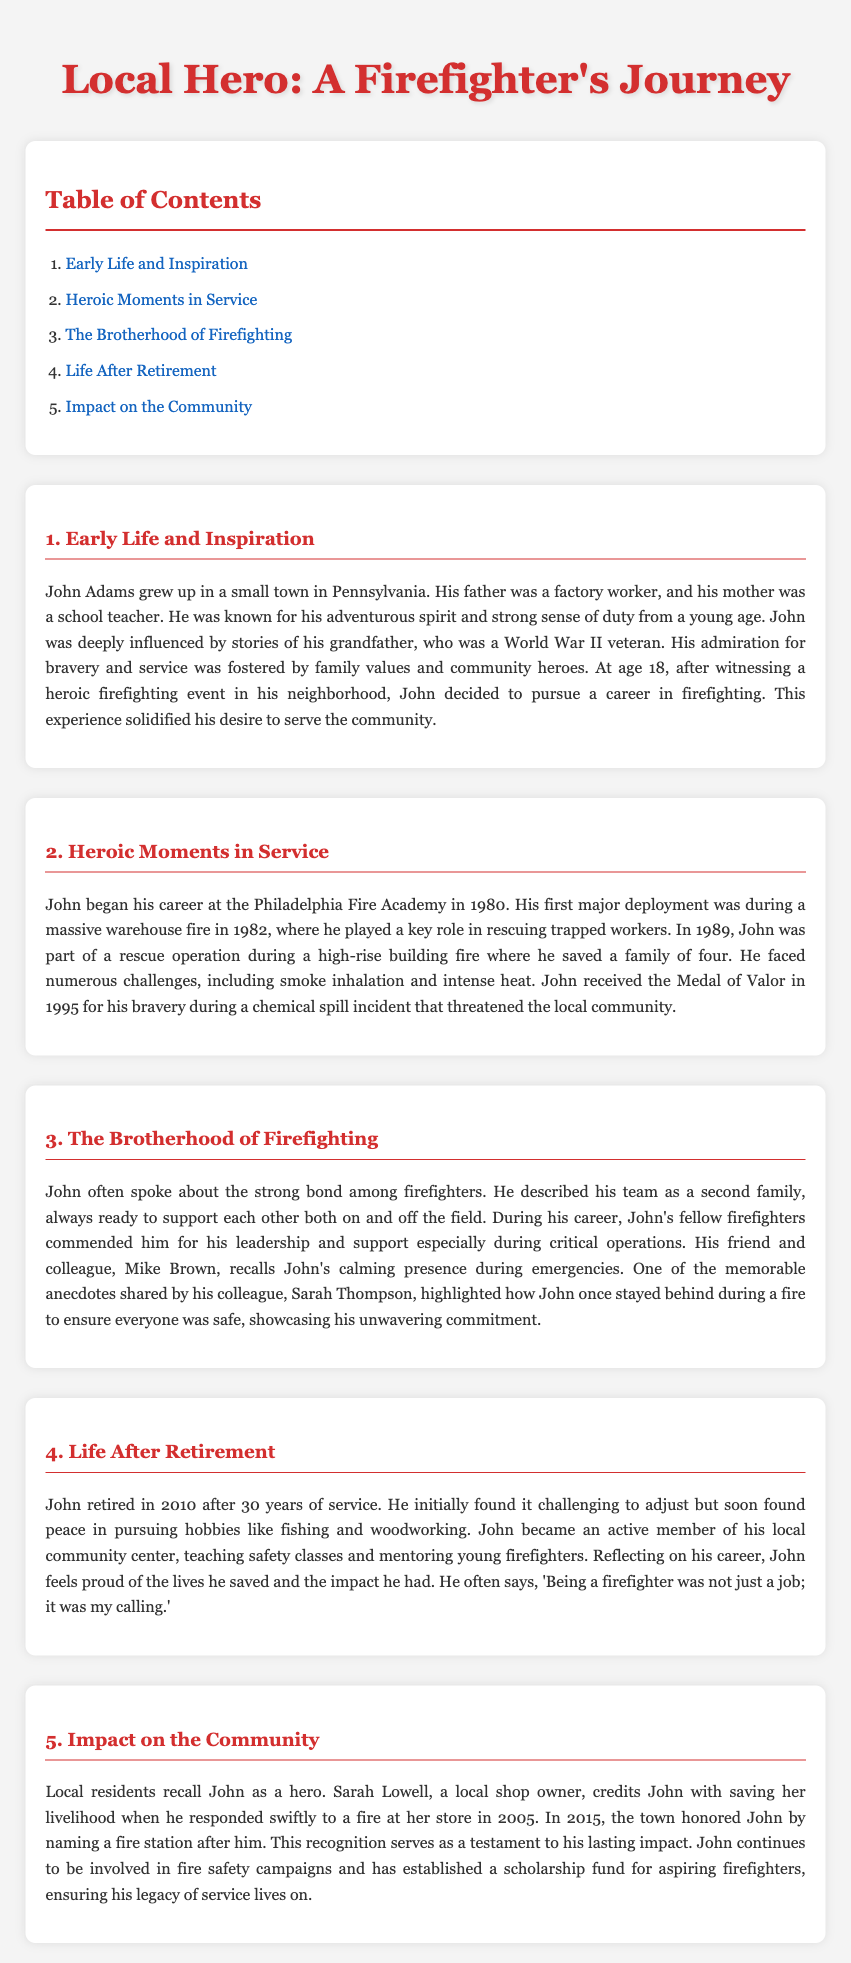What was John Adams' first major deployment? John Adams' first major deployment was during a massive warehouse fire in 1982, as mentioned in the 'Heroic Moments in Service' section.
Answer: warehouse fire Who did John look up to in his childhood? John was influenced by his grandfather, who was a World War II veteran, indicating a strong family background in values of service and bravery.
Answer: grandfather What recognition did John receive in 1995? John received the Medal of Valor in 1995 for his bravery during a chemical spill incident, as stated in the 'Heroic Moments in Service' section.
Answer: Medal of Valor What year did John retire from firefighting? John retired in 2010 after 30 years of service, as noted in the 'Life After Retirement' section.
Answer: 2010 Which community initiative did John establish after his retirement? John established a scholarship fund for aspiring firefighters, as mentioned in the 'Impact on the Community' section.
Answer: scholarship fund What is the main theme of the 'The Brotherhood of Firefighting' section? The main theme revolves around the camaraderie, teamwork, and mutual support among firefighters, as described in that section.
Answer: camaraderie In which town did John grow up? John grew up in a small town in Pennsylvania, as detailed in the 'Early Life and Inspiration' section.
Answer: Pennsylvania What hobby did John pursue after retirement? John found peace in pursuing hobbies like fishing and woodworking, as mentioned in the 'Life After Retirement' section.
Answer: fishing Who credited John with saving her livelihood? Sarah Lowell, a local shop owner, credited John with saving her livelihood when he responded to a fire at her store.
Answer: Sarah Lowell 